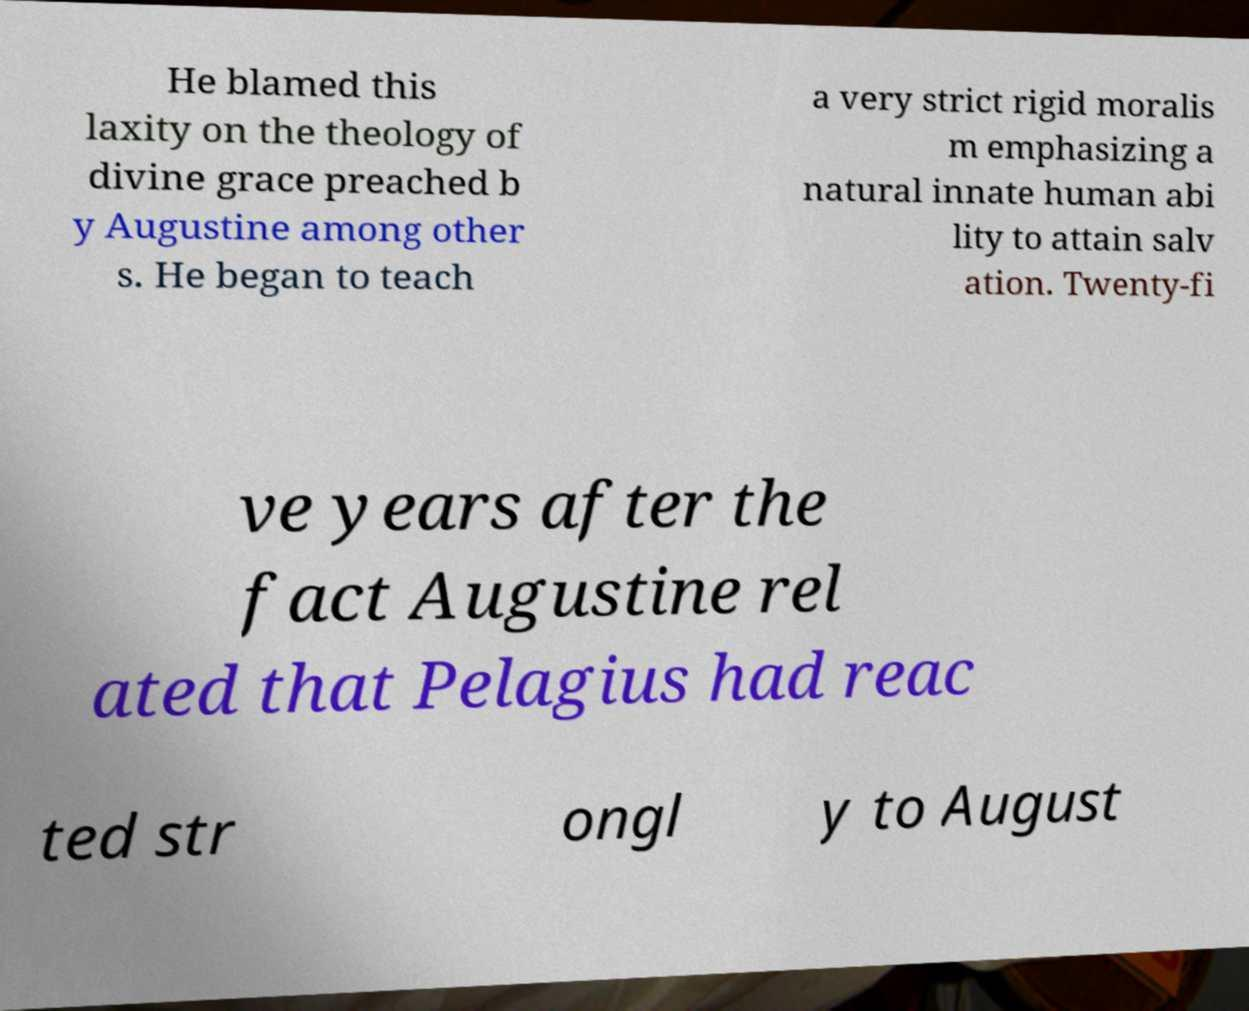I need the written content from this picture converted into text. Can you do that? He blamed this laxity on the theology of divine grace preached b y Augustine among other s. He began to teach a very strict rigid moralis m emphasizing a natural innate human abi lity to attain salv ation. Twenty-fi ve years after the fact Augustine rel ated that Pelagius had reac ted str ongl y to August 